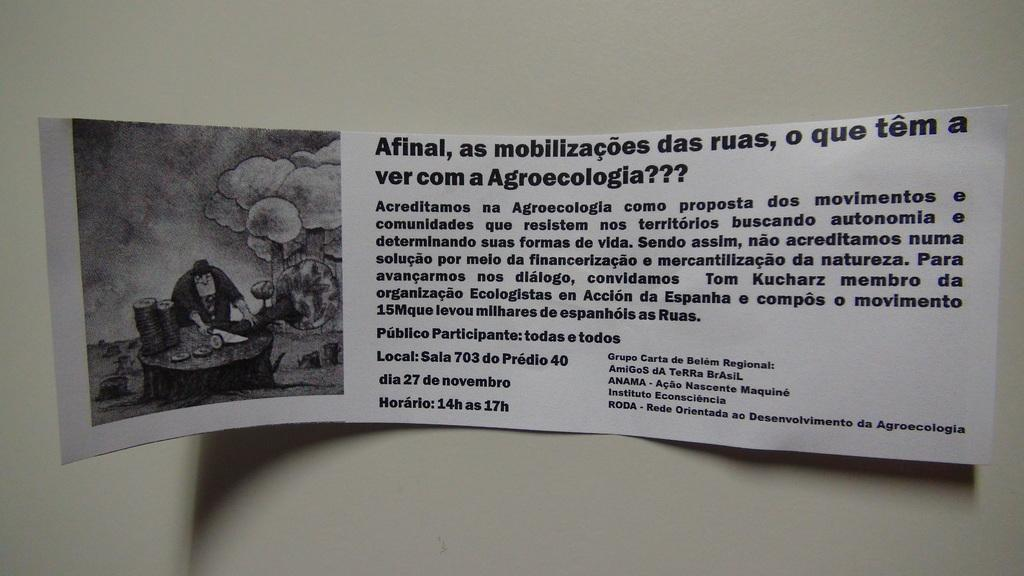What is on the wall in the image? There is a poster on the wall in the image. What elements are included in the poster? The poster contains text and a photo. What type of crack can be seen in the photo on the poster? There is no crack visible in the photo on the poster. How many quarters are depicted in the text on the poster? The text on the poster does not contain any quarters. 